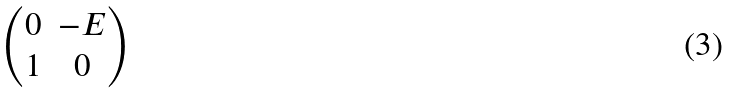<formula> <loc_0><loc_0><loc_500><loc_500>\begin{pmatrix} 0 & - E \\ 1 & 0 \end{pmatrix}</formula> 